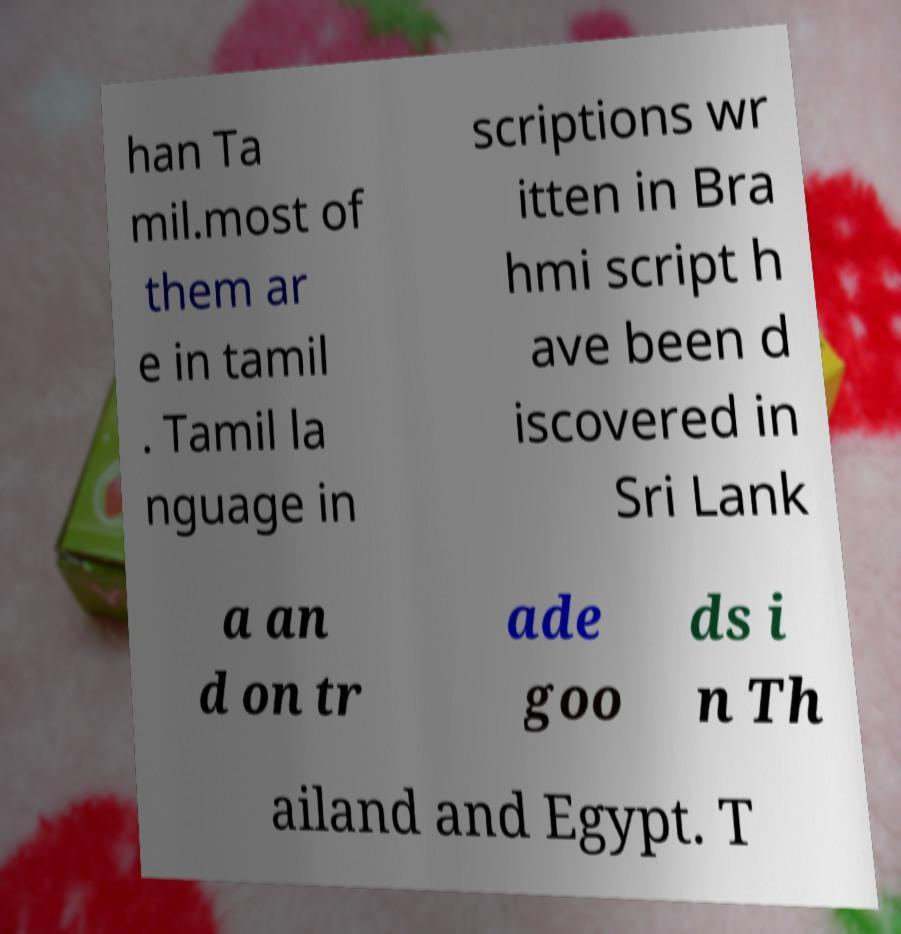Could you extract and type out the text from this image? han Ta mil.most of them ar e in tamil . Tamil la nguage in scriptions wr itten in Bra hmi script h ave been d iscovered in Sri Lank a an d on tr ade goo ds i n Th ailand and Egypt. T 